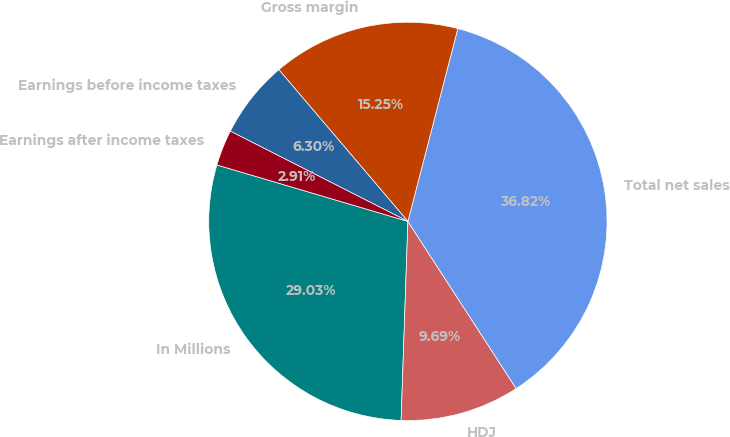Convert chart to OTSL. <chart><loc_0><loc_0><loc_500><loc_500><pie_chart><fcel>In Millions<fcel>HDJ<fcel>Total net sales<fcel>Gross margin<fcel>Earnings before income taxes<fcel>Earnings after income taxes<nl><fcel>29.03%<fcel>9.69%<fcel>36.82%<fcel>15.25%<fcel>6.3%<fcel>2.91%<nl></chart> 